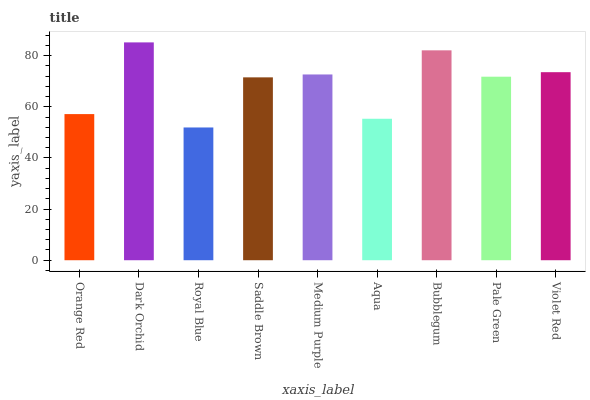Is Royal Blue the minimum?
Answer yes or no. Yes. Is Dark Orchid the maximum?
Answer yes or no. Yes. Is Dark Orchid the minimum?
Answer yes or no. No. Is Royal Blue the maximum?
Answer yes or no. No. Is Dark Orchid greater than Royal Blue?
Answer yes or no. Yes. Is Royal Blue less than Dark Orchid?
Answer yes or no. Yes. Is Royal Blue greater than Dark Orchid?
Answer yes or no. No. Is Dark Orchid less than Royal Blue?
Answer yes or no. No. Is Pale Green the high median?
Answer yes or no. Yes. Is Pale Green the low median?
Answer yes or no. Yes. Is Bubblegum the high median?
Answer yes or no. No. Is Aqua the low median?
Answer yes or no. No. 